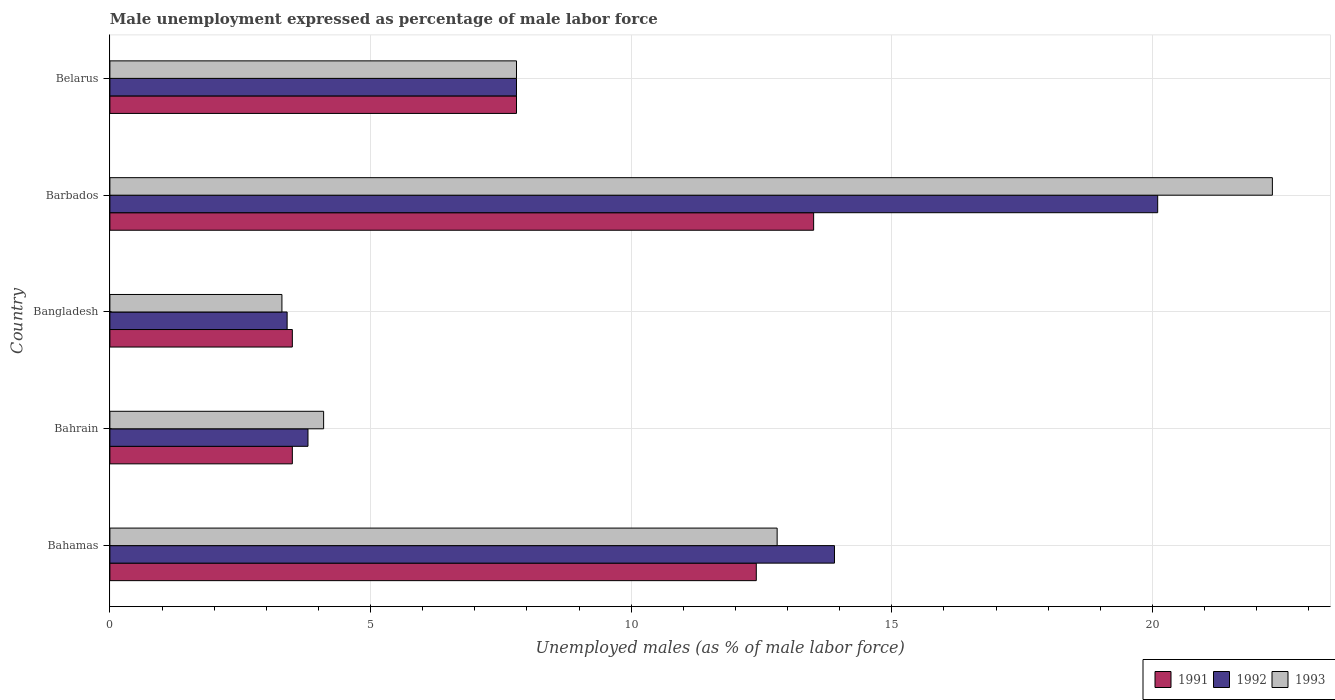How many different coloured bars are there?
Your response must be concise. 3. Are the number of bars per tick equal to the number of legend labels?
Ensure brevity in your answer.  Yes. Are the number of bars on each tick of the Y-axis equal?
Offer a very short reply. Yes. What is the label of the 1st group of bars from the top?
Give a very brief answer. Belarus. What is the unemployment in males in in 1992 in Bahamas?
Your answer should be very brief. 13.9. Across all countries, what is the maximum unemployment in males in in 1992?
Keep it short and to the point. 20.1. In which country was the unemployment in males in in 1993 maximum?
Offer a terse response. Barbados. What is the total unemployment in males in in 1993 in the graph?
Your answer should be very brief. 50.3. What is the difference between the unemployment in males in in 1993 in Bangladesh and that in Belarus?
Provide a short and direct response. -4.5. What is the difference between the unemployment in males in in 1992 in Bangladesh and the unemployment in males in in 1993 in Bahamas?
Make the answer very short. -9.4. What is the average unemployment in males in in 1992 per country?
Ensure brevity in your answer.  9.8. What is the difference between the unemployment in males in in 1991 and unemployment in males in in 1993 in Bangladesh?
Offer a terse response. 0.2. What is the ratio of the unemployment in males in in 1993 in Bangladesh to that in Barbados?
Provide a short and direct response. 0.15. What is the difference between the highest and the second highest unemployment in males in in 1991?
Provide a short and direct response. 1.1. What is the difference between the highest and the lowest unemployment in males in in 1993?
Your response must be concise. 19. Is the sum of the unemployment in males in in 1993 in Bahamas and Belarus greater than the maximum unemployment in males in in 1992 across all countries?
Your answer should be compact. Yes. What does the 1st bar from the bottom in Barbados represents?
Ensure brevity in your answer.  1991. How many bars are there?
Your response must be concise. 15. Are all the bars in the graph horizontal?
Ensure brevity in your answer.  Yes. How many countries are there in the graph?
Your response must be concise. 5. Are the values on the major ticks of X-axis written in scientific E-notation?
Provide a short and direct response. No. Does the graph contain grids?
Offer a terse response. Yes. How are the legend labels stacked?
Your response must be concise. Horizontal. What is the title of the graph?
Your answer should be very brief. Male unemployment expressed as percentage of male labor force. Does "2006" appear as one of the legend labels in the graph?
Offer a very short reply. No. What is the label or title of the X-axis?
Give a very brief answer. Unemployed males (as % of male labor force). What is the Unemployed males (as % of male labor force) of 1991 in Bahamas?
Give a very brief answer. 12.4. What is the Unemployed males (as % of male labor force) in 1992 in Bahamas?
Ensure brevity in your answer.  13.9. What is the Unemployed males (as % of male labor force) in 1993 in Bahamas?
Provide a short and direct response. 12.8. What is the Unemployed males (as % of male labor force) of 1991 in Bahrain?
Keep it short and to the point. 3.5. What is the Unemployed males (as % of male labor force) of 1992 in Bahrain?
Your response must be concise. 3.8. What is the Unemployed males (as % of male labor force) in 1993 in Bahrain?
Your answer should be compact. 4.1. What is the Unemployed males (as % of male labor force) in 1992 in Bangladesh?
Ensure brevity in your answer.  3.4. What is the Unemployed males (as % of male labor force) in 1993 in Bangladesh?
Give a very brief answer. 3.3. What is the Unemployed males (as % of male labor force) of 1992 in Barbados?
Provide a succinct answer. 20.1. What is the Unemployed males (as % of male labor force) of 1993 in Barbados?
Offer a very short reply. 22.3. What is the Unemployed males (as % of male labor force) in 1991 in Belarus?
Offer a very short reply. 7.8. What is the Unemployed males (as % of male labor force) of 1992 in Belarus?
Give a very brief answer. 7.8. What is the Unemployed males (as % of male labor force) of 1993 in Belarus?
Give a very brief answer. 7.8. Across all countries, what is the maximum Unemployed males (as % of male labor force) of 1991?
Keep it short and to the point. 13.5. Across all countries, what is the maximum Unemployed males (as % of male labor force) in 1992?
Make the answer very short. 20.1. Across all countries, what is the maximum Unemployed males (as % of male labor force) of 1993?
Offer a terse response. 22.3. Across all countries, what is the minimum Unemployed males (as % of male labor force) of 1991?
Your answer should be compact. 3.5. Across all countries, what is the minimum Unemployed males (as % of male labor force) of 1992?
Keep it short and to the point. 3.4. Across all countries, what is the minimum Unemployed males (as % of male labor force) of 1993?
Give a very brief answer. 3.3. What is the total Unemployed males (as % of male labor force) of 1991 in the graph?
Your response must be concise. 40.7. What is the total Unemployed males (as % of male labor force) of 1993 in the graph?
Provide a succinct answer. 50.3. What is the difference between the Unemployed males (as % of male labor force) of 1991 in Bahamas and that in Bahrain?
Make the answer very short. 8.9. What is the difference between the Unemployed males (as % of male labor force) in 1993 in Bahamas and that in Bangladesh?
Provide a succinct answer. 9.5. What is the difference between the Unemployed males (as % of male labor force) in 1993 in Bahrain and that in Bangladesh?
Your response must be concise. 0.8. What is the difference between the Unemployed males (as % of male labor force) in 1992 in Bahrain and that in Barbados?
Keep it short and to the point. -16.3. What is the difference between the Unemployed males (as % of male labor force) in 1993 in Bahrain and that in Barbados?
Give a very brief answer. -18.2. What is the difference between the Unemployed males (as % of male labor force) of 1993 in Bahrain and that in Belarus?
Ensure brevity in your answer.  -3.7. What is the difference between the Unemployed males (as % of male labor force) in 1992 in Bangladesh and that in Barbados?
Your response must be concise. -16.7. What is the difference between the Unemployed males (as % of male labor force) of 1993 in Bangladesh and that in Barbados?
Keep it short and to the point. -19. What is the difference between the Unemployed males (as % of male labor force) of 1991 in Bangladesh and that in Belarus?
Keep it short and to the point. -4.3. What is the difference between the Unemployed males (as % of male labor force) in 1992 in Bangladesh and that in Belarus?
Provide a succinct answer. -4.4. What is the difference between the Unemployed males (as % of male labor force) in 1991 in Barbados and that in Belarus?
Make the answer very short. 5.7. What is the difference between the Unemployed males (as % of male labor force) of 1992 in Barbados and that in Belarus?
Your answer should be very brief. 12.3. What is the difference between the Unemployed males (as % of male labor force) of 1991 in Bahamas and the Unemployed males (as % of male labor force) of 1992 in Bangladesh?
Make the answer very short. 9. What is the difference between the Unemployed males (as % of male labor force) of 1991 in Bahamas and the Unemployed males (as % of male labor force) of 1992 in Barbados?
Keep it short and to the point. -7.7. What is the difference between the Unemployed males (as % of male labor force) of 1992 in Bahamas and the Unemployed males (as % of male labor force) of 1993 in Barbados?
Ensure brevity in your answer.  -8.4. What is the difference between the Unemployed males (as % of male labor force) of 1991 in Bahamas and the Unemployed males (as % of male labor force) of 1992 in Belarus?
Provide a succinct answer. 4.6. What is the difference between the Unemployed males (as % of male labor force) in 1991 in Bahrain and the Unemployed males (as % of male labor force) in 1992 in Bangladesh?
Your response must be concise. 0.1. What is the difference between the Unemployed males (as % of male labor force) of 1992 in Bahrain and the Unemployed males (as % of male labor force) of 1993 in Bangladesh?
Keep it short and to the point. 0.5. What is the difference between the Unemployed males (as % of male labor force) of 1991 in Bahrain and the Unemployed males (as % of male labor force) of 1992 in Barbados?
Make the answer very short. -16.6. What is the difference between the Unemployed males (as % of male labor force) in 1991 in Bahrain and the Unemployed males (as % of male labor force) in 1993 in Barbados?
Provide a short and direct response. -18.8. What is the difference between the Unemployed males (as % of male labor force) in 1992 in Bahrain and the Unemployed males (as % of male labor force) in 1993 in Barbados?
Make the answer very short. -18.5. What is the difference between the Unemployed males (as % of male labor force) in 1991 in Bahrain and the Unemployed males (as % of male labor force) in 1993 in Belarus?
Your answer should be compact. -4.3. What is the difference between the Unemployed males (as % of male labor force) of 1992 in Bahrain and the Unemployed males (as % of male labor force) of 1993 in Belarus?
Your response must be concise. -4. What is the difference between the Unemployed males (as % of male labor force) in 1991 in Bangladesh and the Unemployed males (as % of male labor force) in 1992 in Barbados?
Your response must be concise. -16.6. What is the difference between the Unemployed males (as % of male labor force) in 1991 in Bangladesh and the Unemployed males (as % of male labor force) in 1993 in Barbados?
Keep it short and to the point. -18.8. What is the difference between the Unemployed males (as % of male labor force) of 1992 in Bangladesh and the Unemployed males (as % of male labor force) of 1993 in Barbados?
Your answer should be compact. -18.9. What is the difference between the Unemployed males (as % of male labor force) in 1991 in Bangladesh and the Unemployed males (as % of male labor force) in 1992 in Belarus?
Provide a short and direct response. -4.3. What is the difference between the Unemployed males (as % of male labor force) of 1992 in Bangladesh and the Unemployed males (as % of male labor force) of 1993 in Belarus?
Offer a very short reply. -4.4. What is the difference between the Unemployed males (as % of male labor force) in 1991 in Barbados and the Unemployed males (as % of male labor force) in 1993 in Belarus?
Your response must be concise. 5.7. What is the average Unemployed males (as % of male labor force) of 1991 per country?
Provide a succinct answer. 8.14. What is the average Unemployed males (as % of male labor force) in 1993 per country?
Keep it short and to the point. 10.06. What is the difference between the Unemployed males (as % of male labor force) of 1991 and Unemployed males (as % of male labor force) of 1993 in Bahamas?
Make the answer very short. -0.4. What is the difference between the Unemployed males (as % of male labor force) of 1991 and Unemployed males (as % of male labor force) of 1993 in Bahrain?
Your answer should be compact. -0.6. What is the difference between the Unemployed males (as % of male labor force) of 1991 and Unemployed males (as % of male labor force) of 1993 in Bangladesh?
Ensure brevity in your answer.  0.2. What is the difference between the Unemployed males (as % of male labor force) in 1991 and Unemployed males (as % of male labor force) in 1992 in Belarus?
Your response must be concise. 0. What is the ratio of the Unemployed males (as % of male labor force) in 1991 in Bahamas to that in Bahrain?
Your answer should be compact. 3.54. What is the ratio of the Unemployed males (as % of male labor force) in 1992 in Bahamas to that in Bahrain?
Provide a succinct answer. 3.66. What is the ratio of the Unemployed males (as % of male labor force) of 1993 in Bahamas to that in Bahrain?
Offer a terse response. 3.12. What is the ratio of the Unemployed males (as % of male labor force) in 1991 in Bahamas to that in Bangladesh?
Keep it short and to the point. 3.54. What is the ratio of the Unemployed males (as % of male labor force) of 1992 in Bahamas to that in Bangladesh?
Ensure brevity in your answer.  4.09. What is the ratio of the Unemployed males (as % of male labor force) in 1993 in Bahamas to that in Bangladesh?
Your answer should be very brief. 3.88. What is the ratio of the Unemployed males (as % of male labor force) in 1991 in Bahamas to that in Barbados?
Make the answer very short. 0.92. What is the ratio of the Unemployed males (as % of male labor force) in 1992 in Bahamas to that in Barbados?
Offer a terse response. 0.69. What is the ratio of the Unemployed males (as % of male labor force) in 1993 in Bahamas to that in Barbados?
Provide a short and direct response. 0.57. What is the ratio of the Unemployed males (as % of male labor force) in 1991 in Bahamas to that in Belarus?
Offer a very short reply. 1.59. What is the ratio of the Unemployed males (as % of male labor force) in 1992 in Bahamas to that in Belarus?
Your answer should be very brief. 1.78. What is the ratio of the Unemployed males (as % of male labor force) of 1993 in Bahamas to that in Belarus?
Provide a short and direct response. 1.64. What is the ratio of the Unemployed males (as % of male labor force) in 1991 in Bahrain to that in Bangladesh?
Offer a very short reply. 1. What is the ratio of the Unemployed males (as % of male labor force) in 1992 in Bahrain to that in Bangladesh?
Keep it short and to the point. 1.12. What is the ratio of the Unemployed males (as % of male labor force) of 1993 in Bahrain to that in Bangladesh?
Make the answer very short. 1.24. What is the ratio of the Unemployed males (as % of male labor force) of 1991 in Bahrain to that in Barbados?
Your response must be concise. 0.26. What is the ratio of the Unemployed males (as % of male labor force) in 1992 in Bahrain to that in Barbados?
Give a very brief answer. 0.19. What is the ratio of the Unemployed males (as % of male labor force) of 1993 in Bahrain to that in Barbados?
Keep it short and to the point. 0.18. What is the ratio of the Unemployed males (as % of male labor force) of 1991 in Bahrain to that in Belarus?
Offer a terse response. 0.45. What is the ratio of the Unemployed males (as % of male labor force) of 1992 in Bahrain to that in Belarus?
Provide a short and direct response. 0.49. What is the ratio of the Unemployed males (as % of male labor force) in 1993 in Bahrain to that in Belarus?
Your answer should be very brief. 0.53. What is the ratio of the Unemployed males (as % of male labor force) in 1991 in Bangladesh to that in Barbados?
Provide a short and direct response. 0.26. What is the ratio of the Unemployed males (as % of male labor force) of 1992 in Bangladesh to that in Barbados?
Make the answer very short. 0.17. What is the ratio of the Unemployed males (as % of male labor force) of 1993 in Bangladesh to that in Barbados?
Offer a terse response. 0.15. What is the ratio of the Unemployed males (as % of male labor force) of 1991 in Bangladesh to that in Belarus?
Your answer should be very brief. 0.45. What is the ratio of the Unemployed males (as % of male labor force) in 1992 in Bangladesh to that in Belarus?
Your answer should be very brief. 0.44. What is the ratio of the Unemployed males (as % of male labor force) in 1993 in Bangladesh to that in Belarus?
Provide a succinct answer. 0.42. What is the ratio of the Unemployed males (as % of male labor force) in 1991 in Barbados to that in Belarus?
Your answer should be compact. 1.73. What is the ratio of the Unemployed males (as % of male labor force) in 1992 in Barbados to that in Belarus?
Keep it short and to the point. 2.58. What is the ratio of the Unemployed males (as % of male labor force) in 1993 in Barbados to that in Belarus?
Keep it short and to the point. 2.86. What is the difference between the highest and the second highest Unemployed males (as % of male labor force) in 1991?
Provide a short and direct response. 1.1. What is the difference between the highest and the lowest Unemployed males (as % of male labor force) of 1993?
Provide a short and direct response. 19. 